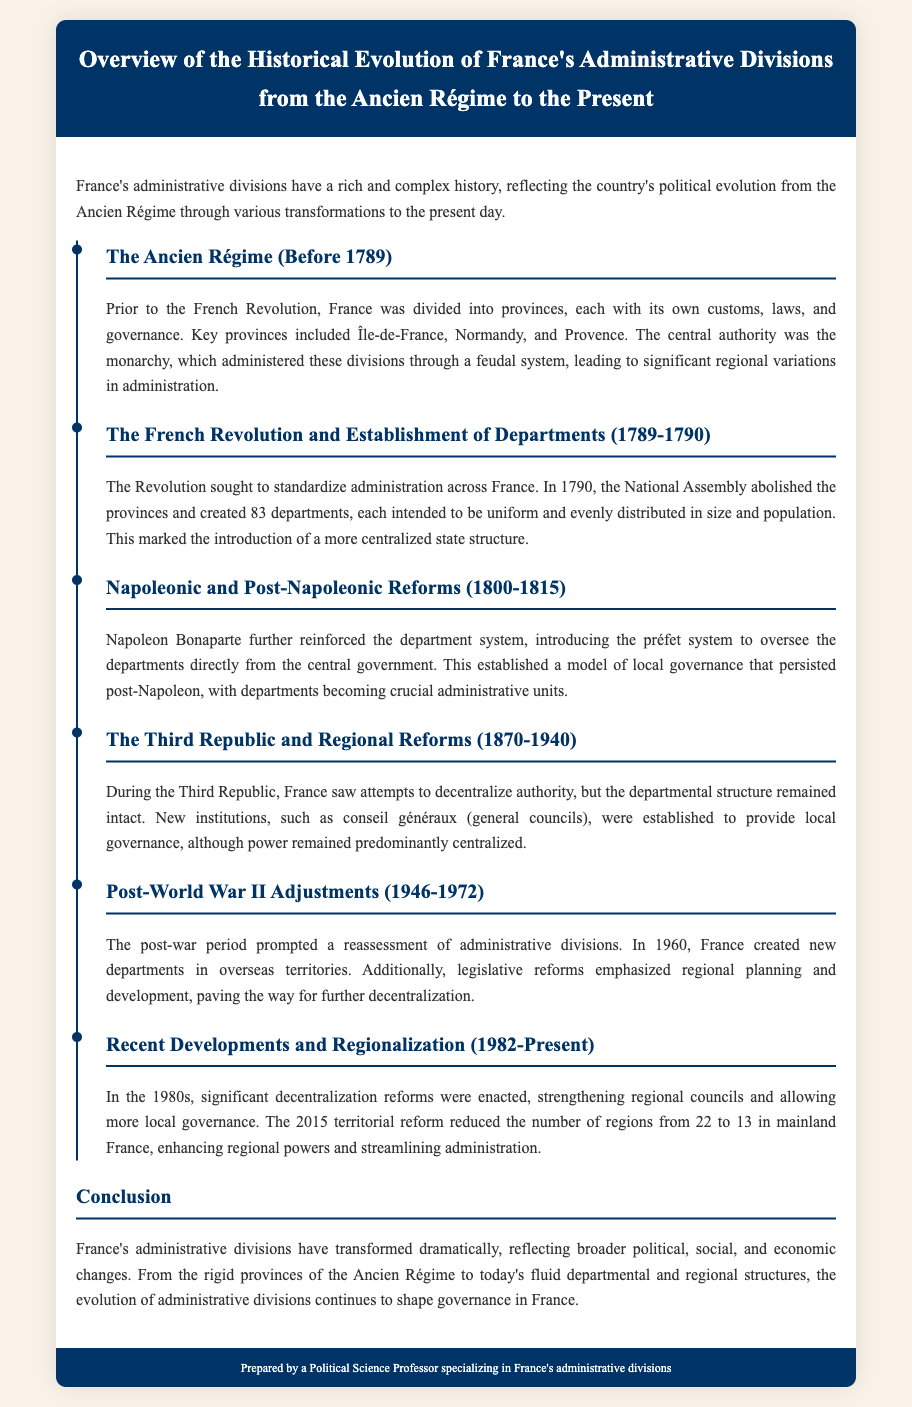What were the key provinces before 1789? The document lists key provinces including Île-de-France, Normandy, and Provence during the Ancien Régime.
Answer: Île-de-France, Normandy, Provence When were the 83 departments established? The establishment of the 83 departments occurred in 1790, following the French Revolution's pursuit of standardized administration.
Answer: 1790 Who introduced the préfet system? The préfet system was introduced by Napoleon Bonaparte to oversee departments directly from the central government.
Answer: Napoleon Bonaparte What was the primary aim of the reforms during the Third Republic? The aim of the reforms during the Third Republic was to decentralize authority while maintaining the existing departmental structure.
Answer: Decentralize authority How many regions were there in mainland France after the 2015 territorial reform? The document states that the number of regions in mainland France was reduced from 22 to 13 after the 2015 territorial reform.
Answer: 13 What prompted the reassessment of administrative divisions after World War II? The document indicates that the post-war period prompted a reassessment of administrative divisions due to the changes stemming from the war.
Answer: Post-war period Which councils were established for local governance during the Third Republic? The document mentions that conseils généraux (general councils) were established during the Third Republic.
Answer: conseils généraux What does the timeline represent in the document? The timeline in the document illustrates the historical evolution of France's administrative divisions from the Ancien Régime to the present.
Answer: Historical evolution 